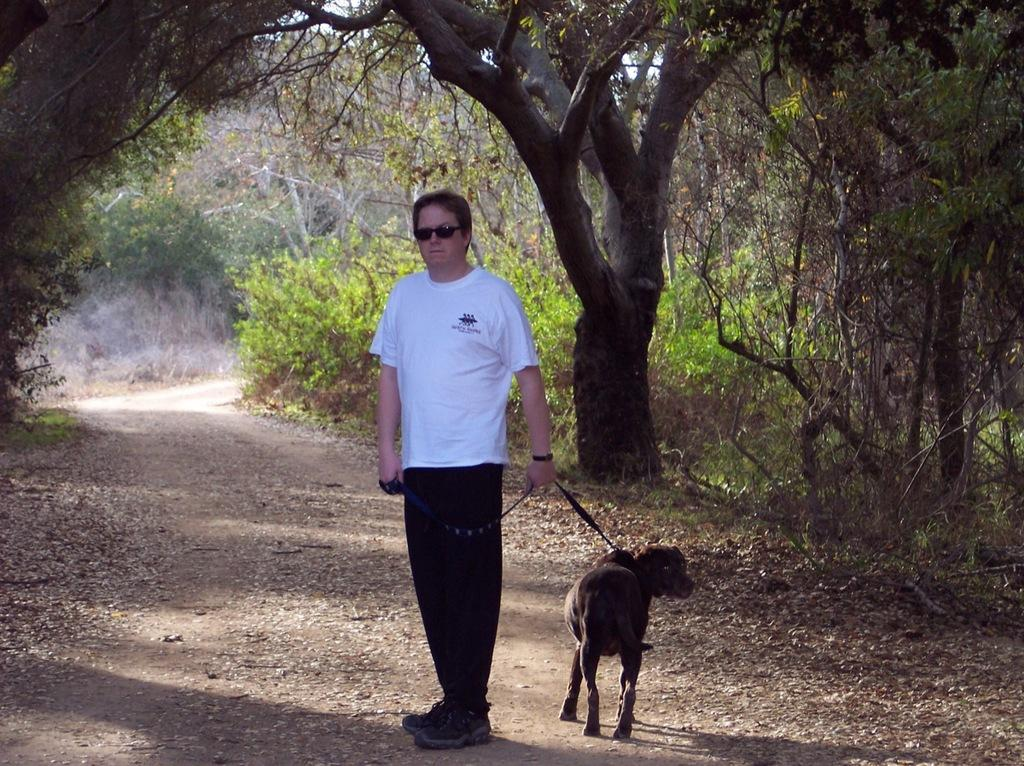Who is the person in the image? There is a man in the image. What is the man wearing? The man is wearing a white and black dress, goggles, and a watch. What is the man holding in the image? The man is holding a dog with a belt. Where is the man standing? The man is standing on a pathway. What can be seen on the sides of the pathway? There are trees on the sides of the pathway. What type of whip is the man using to control the dog in the image? There is no whip present in the image; the man is holding a dog with a belt. Can you tell me what hospital the man is visiting in the image? There is no indication of a hospital or any medical-related activity in the image. 